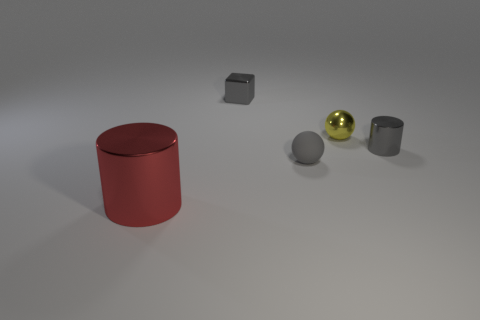Add 2 small metallic cubes. How many objects exist? 7 Subtract all blocks. How many objects are left? 4 Add 3 small gray metal cylinders. How many small gray metal cylinders are left? 4 Add 2 yellow metallic objects. How many yellow metallic objects exist? 3 Subtract 0 blue cubes. How many objects are left? 5 Subtract all tiny cubes. Subtract all metal balls. How many objects are left? 3 